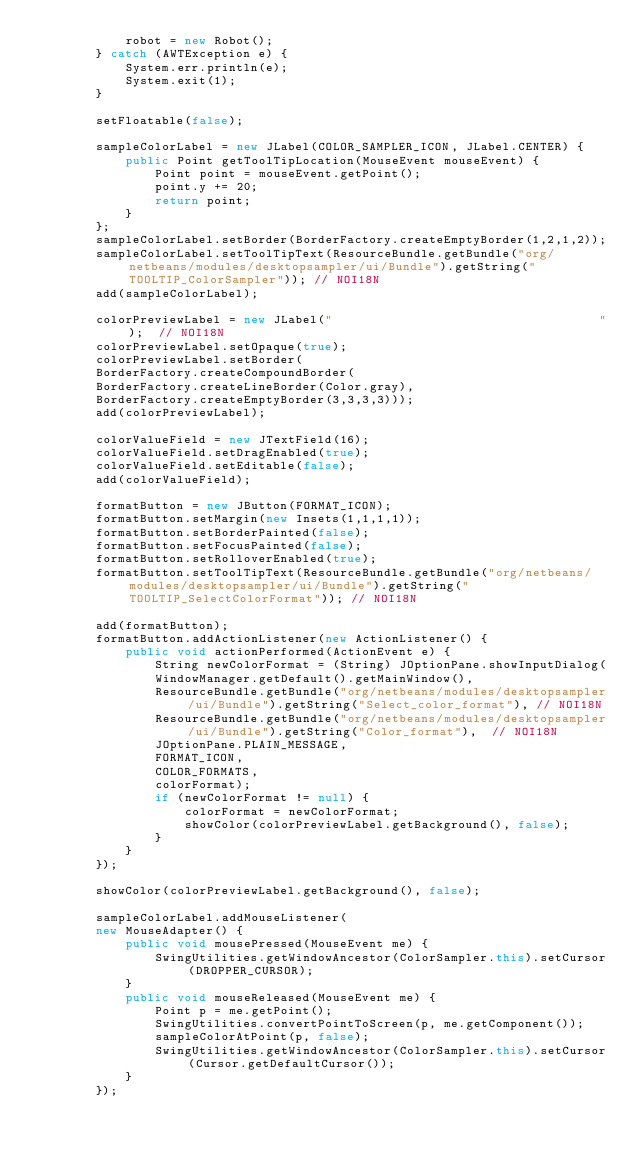Convert code to text. <code><loc_0><loc_0><loc_500><loc_500><_Java_>            robot = new Robot();
        } catch (AWTException e) {
            System.err.println(e);
            System.exit(1);
        }
        
        setFloatable(false);
        
        sampleColorLabel = new JLabel(COLOR_SAMPLER_ICON, JLabel.CENTER) {
            public Point getToolTipLocation(MouseEvent mouseEvent) {
                Point point = mouseEvent.getPoint();
                point.y += 20;
                return point;
            }
        };
        sampleColorLabel.setBorder(BorderFactory.createEmptyBorder(1,2,1,2));
        sampleColorLabel.setToolTipText(ResourceBundle.getBundle("org/netbeans/modules/desktopsampler/ui/Bundle").getString("TOOLTIP_ColorSampler")); // NOI18N       
        add(sampleColorLabel);
        
        colorPreviewLabel = new JLabel("                                    ");  // NOI18N
        colorPreviewLabel.setOpaque(true);
        colorPreviewLabel.setBorder(
        BorderFactory.createCompoundBorder(
        BorderFactory.createLineBorder(Color.gray),
        BorderFactory.createEmptyBorder(3,3,3,3)));
        add(colorPreviewLabel);
        
        colorValueField = new JTextField(16);
        colorValueField.setDragEnabled(true);
        colorValueField.setEditable(false);
        add(colorValueField);
        
        formatButton = new JButton(FORMAT_ICON);
        formatButton.setMargin(new Insets(1,1,1,1));
        formatButton.setBorderPainted(false);
        formatButton.setFocusPainted(false);
        formatButton.setRolloverEnabled(true);
        formatButton.setToolTipText(ResourceBundle.getBundle("org/netbeans/modules/desktopsampler/ui/Bundle").getString("TOOLTIP_SelectColorFormat")); // NOI18N
        
        add(formatButton);
        formatButton.addActionListener(new ActionListener() {
            public void actionPerformed(ActionEvent e) {
                String newColorFormat = (String) JOptionPane.showInputDialog(
                WindowManager.getDefault().getMainWindow(),
                ResourceBundle.getBundle("org/netbeans/modules/desktopsampler/ui/Bundle").getString("Select_color_format"), // NOI18N
                ResourceBundle.getBundle("org/netbeans/modules/desktopsampler/ui/Bundle").getString("Color_format"),  // NOI18N
                JOptionPane.PLAIN_MESSAGE,
                FORMAT_ICON,
                COLOR_FORMATS,
                colorFormat);
                if (newColorFormat != null) {
                    colorFormat = newColorFormat;
                    showColor(colorPreviewLabel.getBackground(), false);
                }
            }
        });
        
        showColor(colorPreviewLabel.getBackground(), false);
        
        sampleColorLabel.addMouseListener(
        new MouseAdapter() {
            public void mousePressed(MouseEvent me) {
                SwingUtilities.getWindowAncestor(ColorSampler.this).setCursor(DROPPER_CURSOR);
            }
            public void mouseReleased(MouseEvent me) {
                Point p = me.getPoint();
                SwingUtilities.convertPointToScreen(p, me.getComponent());
                sampleColorAtPoint(p, false);
                SwingUtilities.getWindowAncestor(ColorSampler.this).setCursor(Cursor.getDefaultCursor());
            }
        });
        </code> 